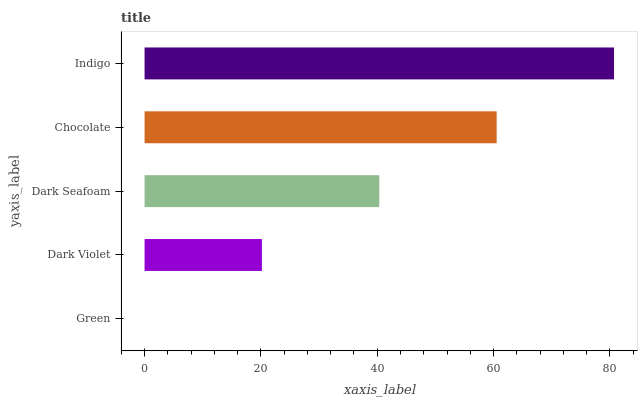Is Green the minimum?
Answer yes or no. Yes. Is Indigo the maximum?
Answer yes or no. Yes. Is Dark Violet the minimum?
Answer yes or no. No. Is Dark Violet the maximum?
Answer yes or no. No. Is Dark Violet greater than Green?
Answer yes or no. Yes. Is Green less than Dark Violet?
Answer yes or no. Yes. Is Green greater than Dark Violet?
Answer yes or no. No. Is Dark Violet less than Green?
Answer yes or no. No. Is Dark Seafoam the high median?
Answer yes or no. Yes. Is Dark Seafoam the low median?
Answer yes or no. Yes. Is Green the high median?
Answer yes or no. No. Is Chocolate the low median?
Answer yes or no. No. 